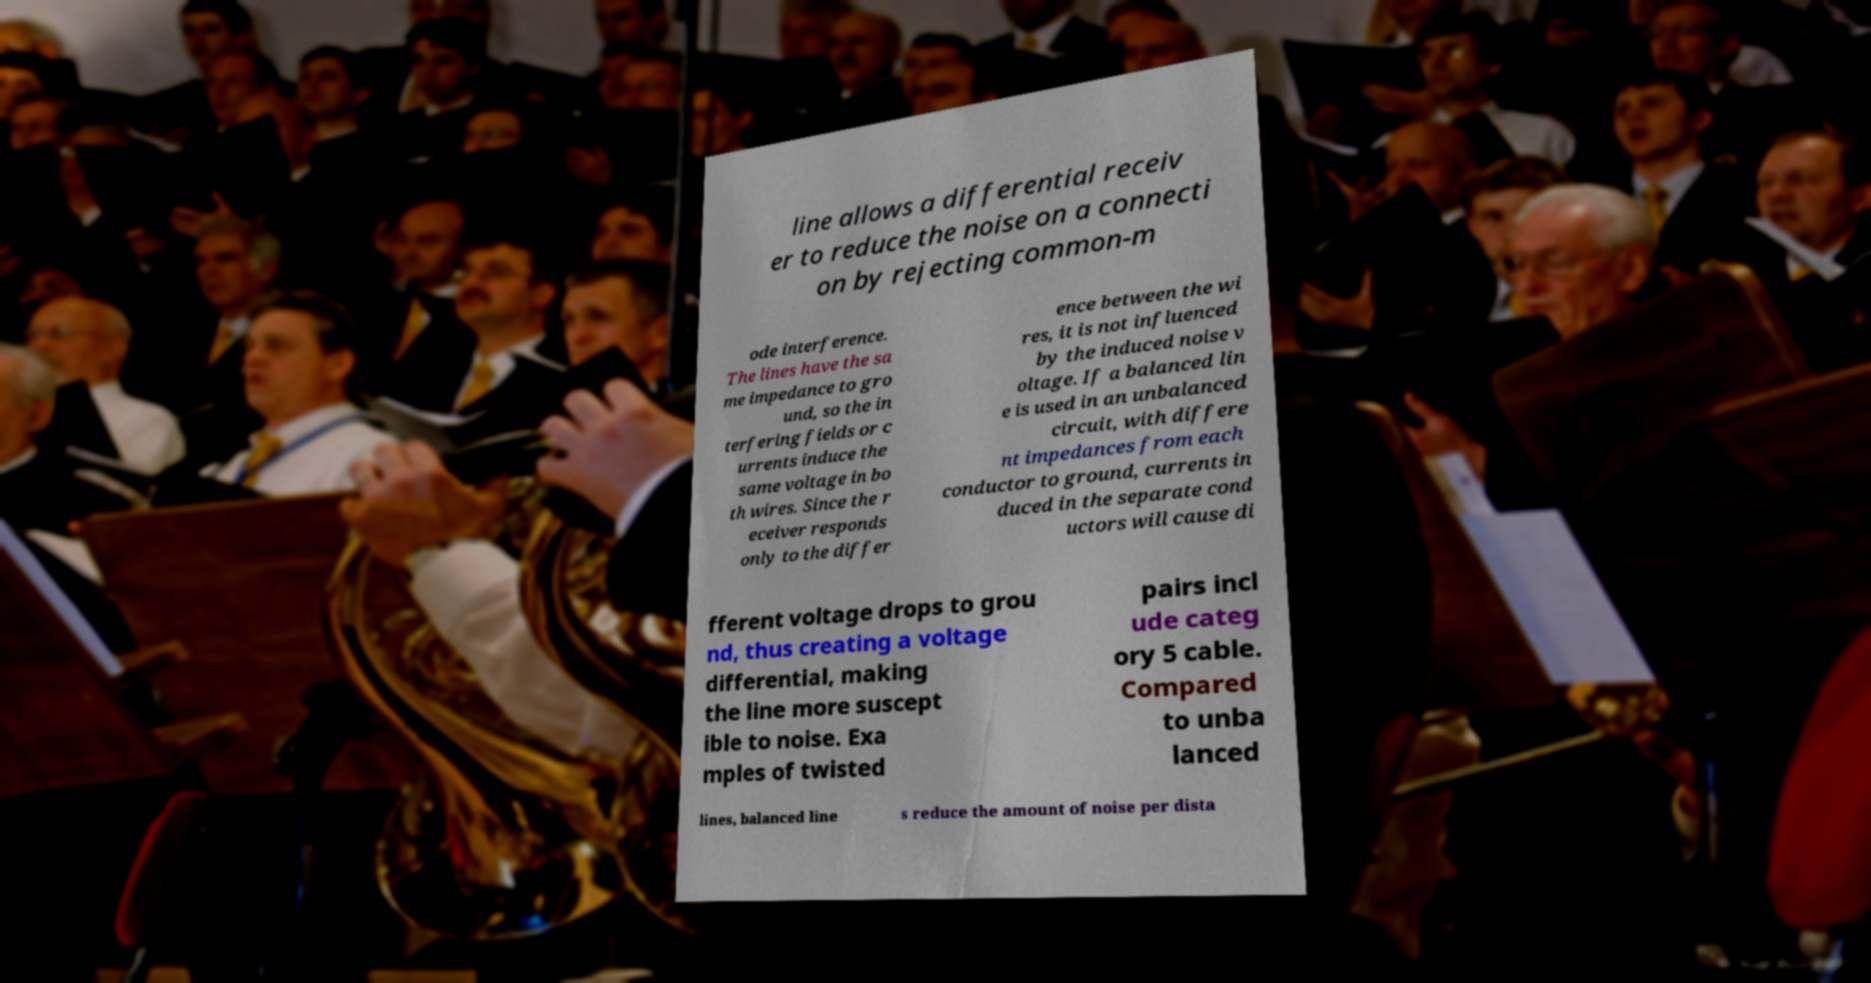What messages or text are displayed in this image? I need them in a readable, typed format. line allows a differential receiv er to reduce the noise on a connecti on by rejecting common-m ode interference. The lines have the sa me impedance to gro und, so the in terfering fields or c urrents induce the same voltage in bo th wires. Since the r eceiver responds only to the differ ence between the wi res, it is not influenced by the induced noise v oltage. If a balanced lin e is used in an unbalanced circuit, with differe nt impedances from each conductor to ground, currents in duced in the separate cond uctors will cause di fferent voltage drops to grou nd, thus creating a voltage differential, making the line more suscept ible to noise. Exa mples of twisted pairs incl ude categ ory 5 cable. Compared to unba lanced lines, balanced line s reduce the amount of noise per dista 